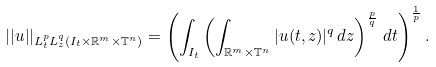Convert formula to latex. <formula><loc_0><loc_0><loc_500><loc_500>| | u | | _ { L ^ { p } _ { t } L ^ { q } _ { z } ( I _ { t } \times \mathbb { R } ^ { m } \times \mathbb { T } ^ { n } ) } = \left ( \int _ { I _ { t } } \left ( \int _ { \mathbb { R } ^ { m } \times \mathbb { T } ^ { n } } | u ( t , z ) | ^ { q } \, d z \right ) ^ { \frac { p } { q } } \, d t \right ) ^ { \frac { 1 } { p } } .</formula> 